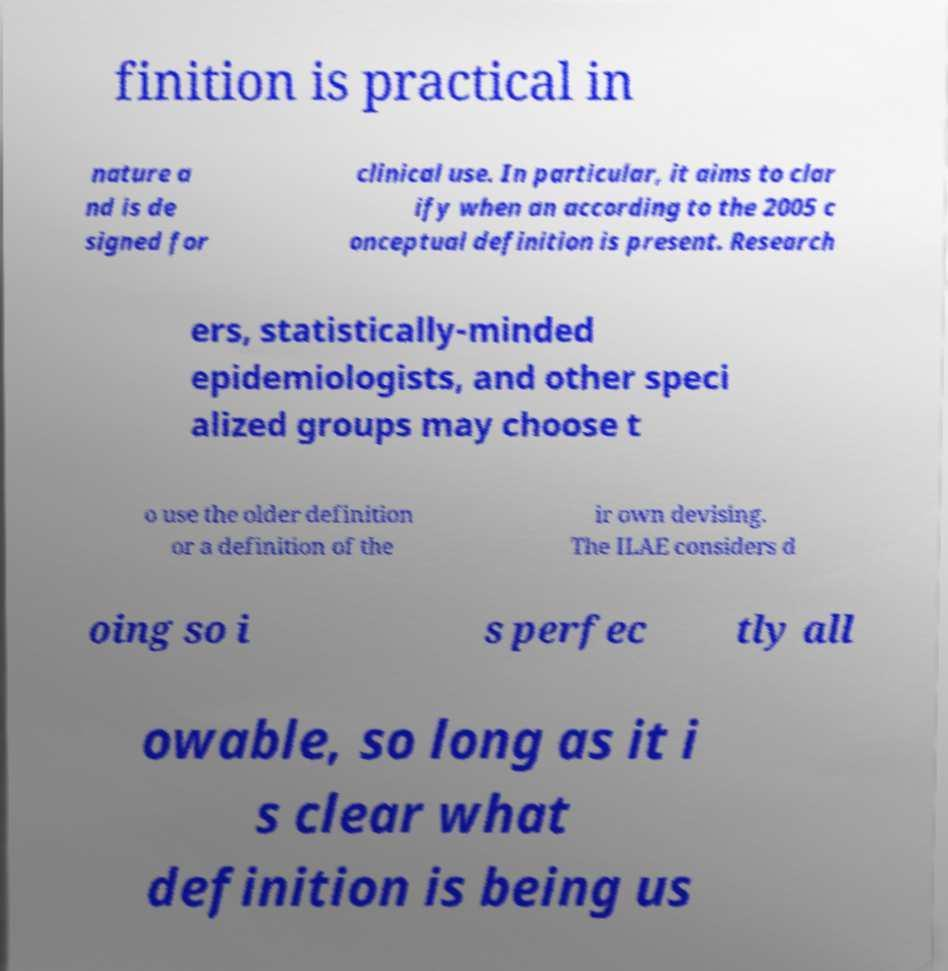Please identify and transcribe the text found in this image. finition is practical in nature a nd is de signed for clinical use. In particular, it aims to clar ify when an according to the 2005 c onceptual definition is present. Research ers, statistically-minded epidemiologists, and other speci alized groups may choose t o use the older definition or a definition of the ir own devising. The ILAE considers d oing so i s perfec tly all owable, so long as it i s clear what definition is being us 